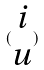<formula> <loc_0><loc_0><loc_500><loc_500>( \begin{matrix} i \\ u \end{matrix} )</formula> 